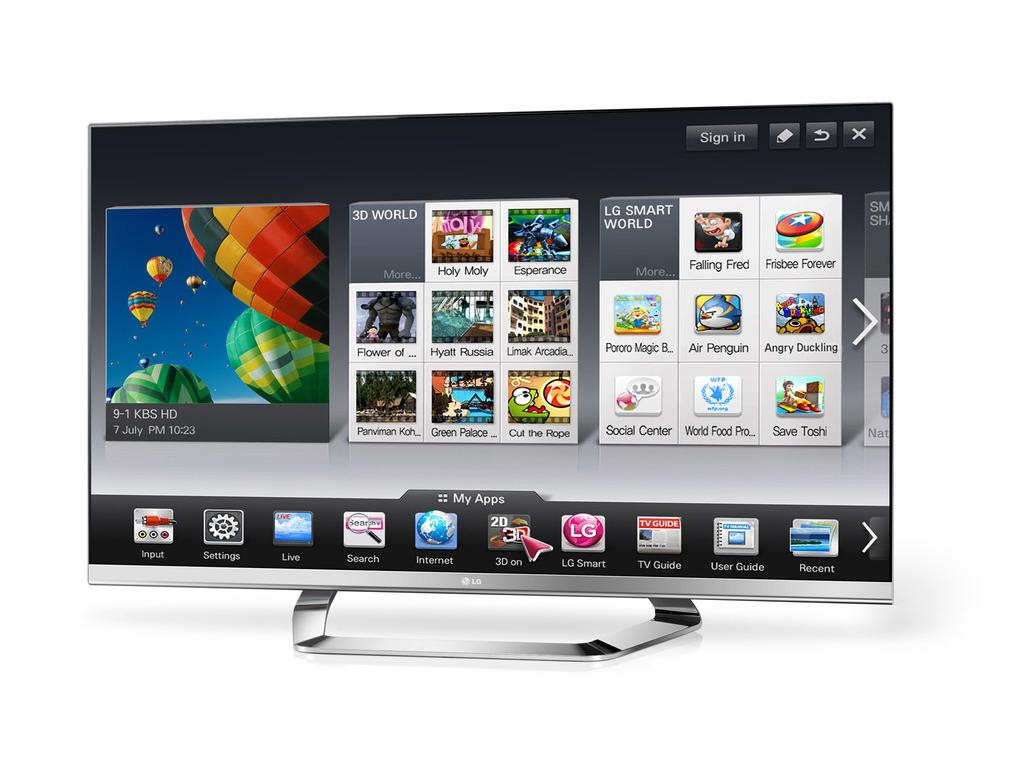What electronic device is present in the image? There is a television in the image. What is being displayed on the television screen? The television screen displays parachutes, the sky, and logos. What type of cloth is being used to make the parachutes in the image? There is no cloth present in the image, as the parachutes are displayed on the television screen. 